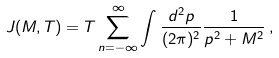<formula> <loc_0><loc_0><loc_500><loc_500>J ( M , T ) = T \sum ^ { \infty } _ { n = - \infty } \int \frac { d ^ { 2 } p } { ( 2 \pi ) ^ { 2 } } \frac { 1 } { p ^ { 2 } + M ^ { 2 } } \, ,</formula> 